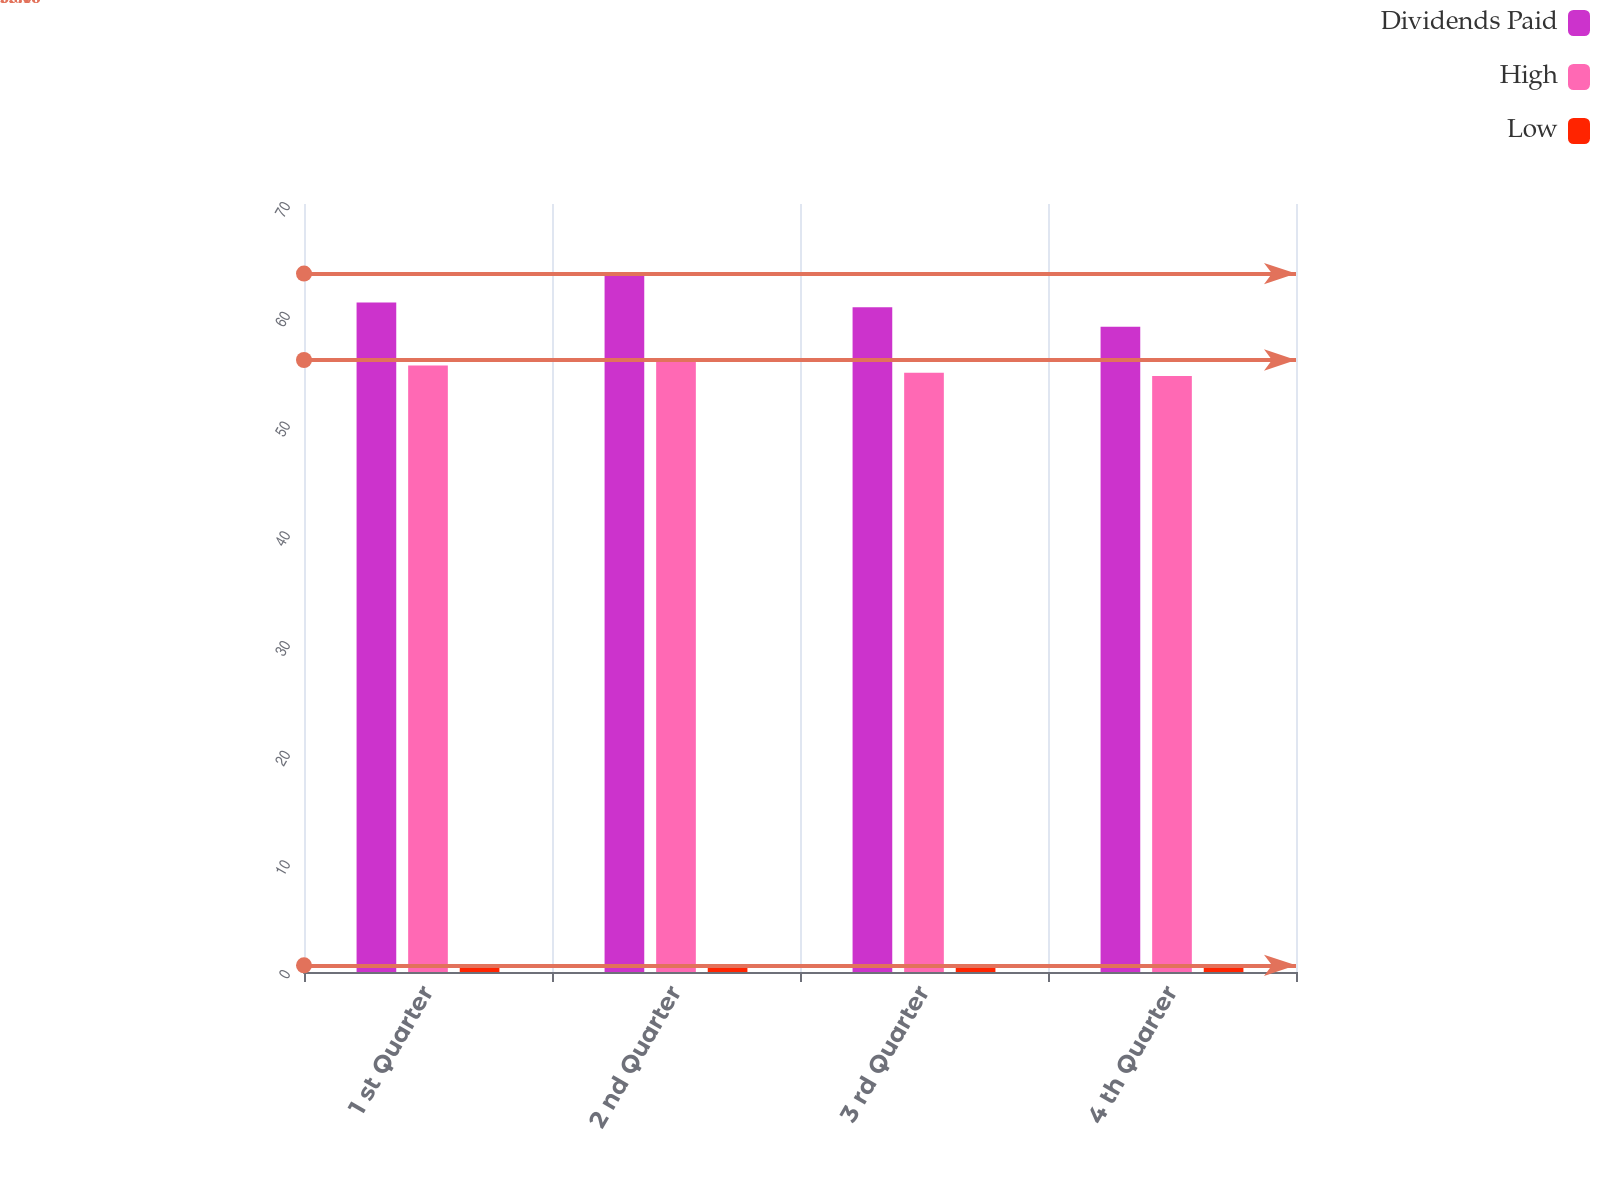<chart> <loc_0><loc_0><loc_500><loc_500><stacked_bar_chart><ecel><fcel>1 st Quarter<fcel>2 nd Quarter<fcel>3 rd Quarter<fcel>4 th Quarter<nl><fcel>Dividends Paid<fcel>61.03<fcel>63.66<fcel>60.59<fcel>58.82<nl><fcel>High<fcel>55.28<fcel>55.78<fcel>54.63<fcel>54.33<nl><fcel>Low<fcel>0.61<fcel>0.61<fcel>0.61<fcel>0.61<nl></chart> 